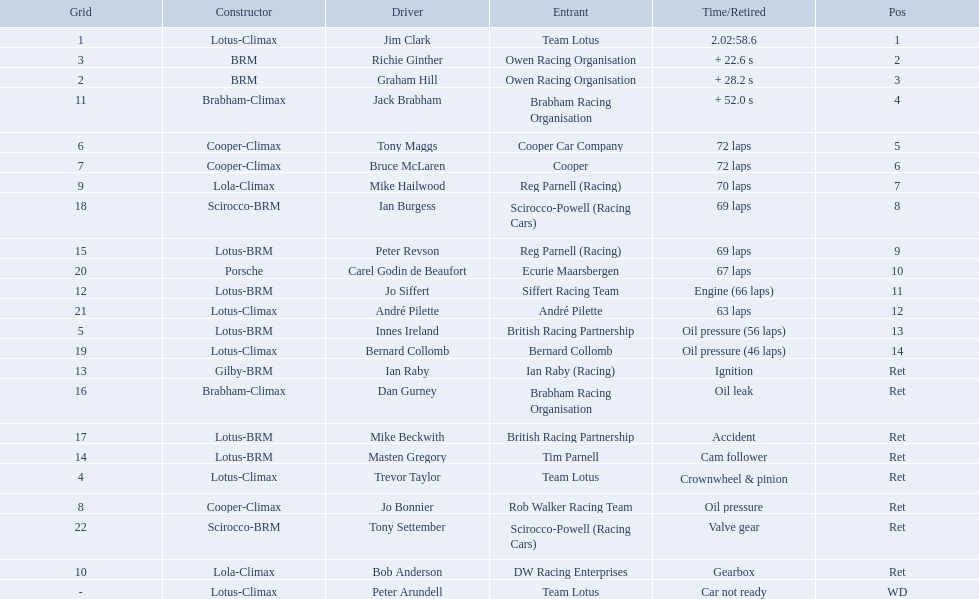Who drove in the 1963 international gold cup? Jim Clark, Richie Ginther, Graham Hill, Jack Brabham, Tony Maggs, Bruce McLaren, Mike Hailwood, Ian Burgess, Peter Revson, Carel Godin de Beaufort, Jo Siffert, André Pilette, Innes Ireland, Bernard Collomb, Ian Raby, Dan Gurney, Mike Beckwith, Masten Gregory, Trevor Taylor, Jo Bonnier, Tony Settember, Bob Anderson, Peter Arundell. Who had problems during the race? Jo Siffert, Innes Ireland, Bernard Collomb, Ian Raby, Dan Gurney, Mike Beckwith, Masten Gregory, Trevor Taylor, Jo Bonnier, Tony Settember, Bob Anderson, Peter Arundell. Of those who was still able to finish the race? Jo Siffert, Innes Ireland, Bernard Collomb. Of those who faced the same issue? Innes Ireland, Bernard Collomb. What issue did they have? Oil pressure. Who are all the drivers? Jim Clark, Richie Ginther, Graham Hill, Jack Brabham, Tony Maggs, Bruce McLaren, Mike Hailwood, Ian Burgess, Peter Revson, Carel Godin de Beaufort, Jo Siffert, André Pilette, Innes Ireland, Bernard Collomb, Ian Raby, Dan Gurney, Mike Beckwith, Masten Gregory, Trevor Taylor, Jo Bonnier, Tony Settember, Bob Anderson, Peter Arundell. What were their positions? 1, 2, 3, 4, 5, 6, 7, 8, 9, 10, 11, 12, 13, 14, Ret, Ret, Ret, Ret, Ret, Ret, Ret, Ret, WD. What are all the constructor names? Lotus-Climax, BRM, BRM, Brabham-Climax, Cooper-Climax, Cooper-Climax, Lola-Climax, Scirocco-BRM, Lotus-BRM, Porsche, Lotus-BRM, Lotus-Climax, Lotus-BRM, Lotus-Climax, Gilby-BRM, Brabham-Climax, Lotus-BRM, Lotus-BRM, Lotus-Climax, Cooper-Climax, Scirocco-BRM, Lola-Climax, Lotus-Climax. And which drivers drove a cooper-climax? Tony Maggs, Bruce McLaren. Between those tow, who was positioned higher? Tony Maggs. Who are all the drivers? Jim Clark, Richie Ginther, Graham Hill, Jack Brabham, Tony Maggs, Bruce McLaren, Mike Hailwood, Ian Burgess, Peter Revson, Carel Godin de Beaufort, Jo Siffert, André Pilette, Innes Ireland, Bernard Collomb, Ian Raby, Dan Gurney, Mike Beckwith, Masten Gregory, Trevor Taylor, Jo Bonnier, Tony Settember, Bob Anderson, Peter Arundell. Which drove a cooper-climax? Tony Maggs, Bruce McLaren, Jo Bonnier. Of those, who was the top finisher? Tony Maggs. 